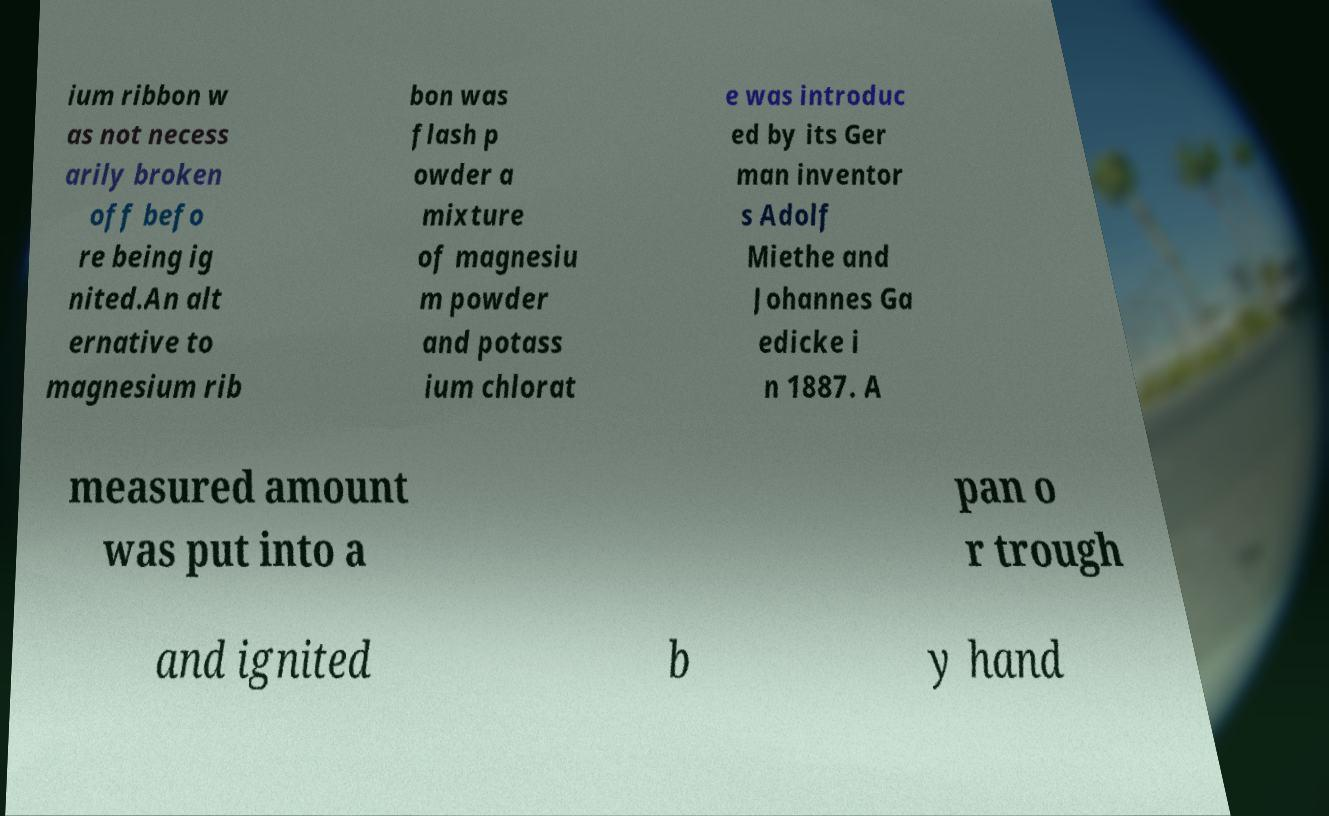What messages or text are displayed in this image? I need them in a readable, typed format. ium ribbon w as not necess arily broken off befo re being ig nited.An alt ernative to magnesium rib bon was flash p owder a mixture of magnesiu m powder and potass ium chlorat e was introduc ed by its Ger man inventor s Adolf Miethe and Johannes Ga edicke i n 1887. A measured amount was put into a pan o r trough and ignited b y hand 